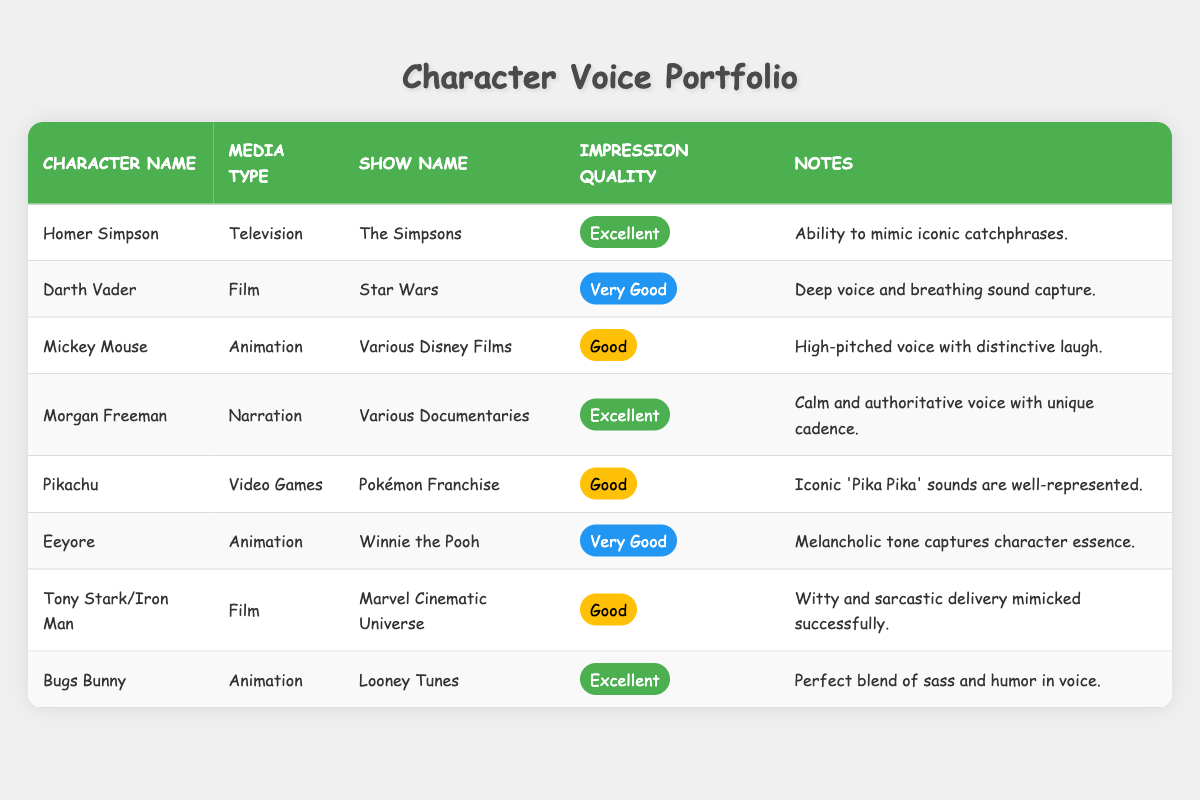What is the impression quality of Homer Simpson? The table indicates that Homer Simpson has an impression quality labeled as "Excellent."
Answer: Excellent Which character has the highest impression quality in the portfolio? By comparing the impression quality of all characters, it is clear that both Homer Simpson and Bugs Bunny have the highest quality listed as "Excellent."
Answer: Homer Simpson and Bugs Bunny Is Morgan Freeman featured in a television show? The table shows that Morgan Freeman is involved with narration for various documentaries, not television shows. Therefore, the answer is false.
Answer: No What kind of media type does Pikachu fall under? According to the table, Pikachu is categorized under "Video Games."
Answer: Video Games Count the number of characters with an impression quality marked as "Very Good." From the table, Eeyore and Darth Vader are marked "Very Good," which sums up to two characters.
Answer: 2 Which characters are associated with animation? The characters listed under the animation media type are Mickey Mouse, Eeyore, and Bugs Bunny.
Answer: Mickey Mouse, Eeyore, Bugs Bunny What is the average impression quality rating based on the categories provided? The impression qualities (Excellent, Very Good, Good) can be assigned numerical values (Excellent=3, Very Good=2, Good=1). There are 8 characters with qualities totaling (3 + 2 + 1 + 3 + 1 + 2 + 1 + 3) = 16. Dividing by 8 gives an average quality of 2, corresponding to "Very Good."
Answer: Very Good Does Eeyore have a better impression quality than Tony Stark/Iron Man? Eeyore is rated "Very Good" while Tony Stark/Iron Man is rated "Good." Thus, Eeyore has a better impression quality than Tony Stark/Iron Man, making this statement true.
Answer: Yes Which character's impression includes iconic catchphrases? The notes for Homer Simpson specifically mention the ability to mimic iconic catchphrases, indicating that this character fits the description.
Answer: Homer Simpson 